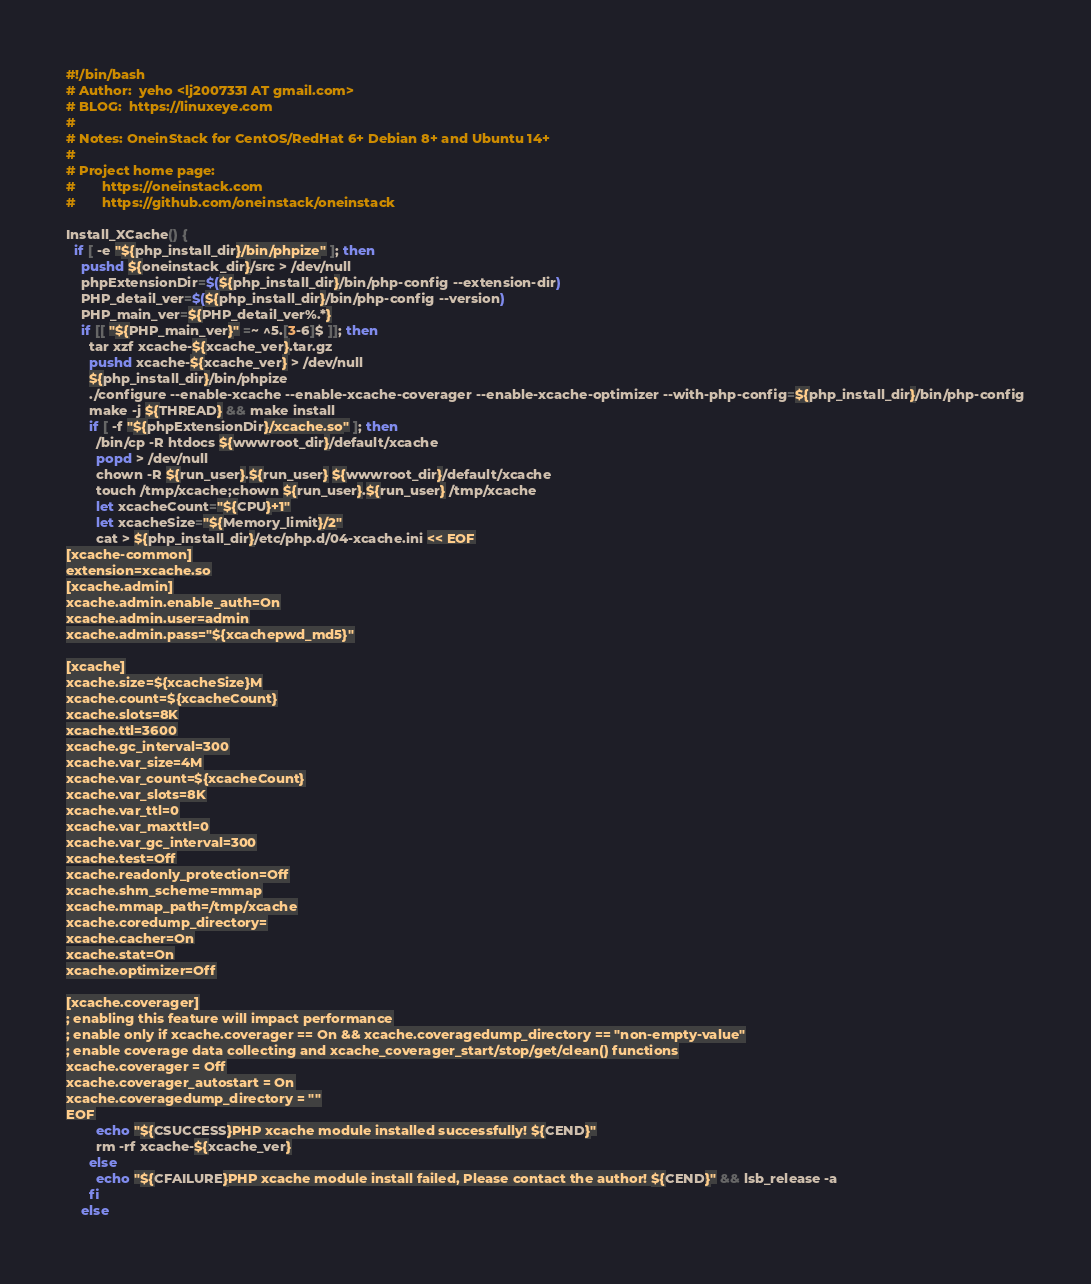Convert code to text. <code><loc_0><loc_0><loc_500><loc_500><_Bash_>#!/bin/bash
# Author:  yeho <lj2007331 AT gmail.com>
# BLOG:  https://linuxeye.com
#
# Notes: OneinStack for CentOS/RedHat 6+ Debian 8+ and Ubuntu 14+
#
# Project home page:
#       https://oneinstack.com
#       https://github.com/oneinstack/oneinstack

Install_XCache() {
  if [ -e "${php_install_dir}/bin/phpize" ]; then
    pushd ${oneinstack_dir}/src > /dev/null
    phpExtensionDir=$(${php_install_dir}/bin/php-config --extension-dir)
    PHP_detail_ver=$(${php_install_dir}/bin/php-config --version)
    PHP_main_ver=${PHP_detail_ver%.*}
    if [[ "${PHP_main_ver}" =~ ^5.[3-6]$ ]]; then
      tar xzf xcache-${xcache_ver}.tar.gz
      pushd xcache-${xcache_ver} > /dev/null
      ${php_install_dir}/bin/phpize
      ./configure --enable-xcache --enable-xcache-coverager --enable-xcache-optimizer --with-php-config=${php_install_dir}/bin/php-config
      make -j ${THREAD} && make install
      if [ -f "${phpExtensionDir}/xcache.so" ]; then
        /bin/cp -R htdocs ${wwwroot_dir}/default/xcache
        popd > /dev/null
        chown -R ${run_user}.${run_user} ${wwwroot_dir}/default/xcache
        touch /tmp/xcache;chown ${run_user}.${run_user} /tmp/xcache
        let xcacheCount="${CPU}+1"
        let xcacheSize="${Memory_limit}/2"
        cat > ${php_install_dir}/etc/php.d/04-xcache.ini << EOF
[xcache-common]
extension=xcache.so
[xcache.admin]
xcache.admin.enable_auth=On
xcache.admin.user=admin
xcache.admin.pass="${xcachepwd_md5}"

[xcache]
xcache.size=${xcacheSize}M
xcache.count=${xcacheCount}
xcache.slots=8K
xcache.ttl=3600
xcache.gc_interval=300
xcache.var_size=4M
xcache.var_count=${xcacheCount}
xcache.var_slots=8K
xcache.var_ttl=0
xcache.var_maxttl=0
xcache.var_gc_interval=300
xcache.test=Off
xcache.readonly_protection=Off
xcache.shm_scheme=mmap
xcache.mmap_path=/tmp/xcache
xcache.coredump_directory=
xcache.cacher=On
xcache.stat=On
xcache.optimizer=Off

[xcache.coverager]
; enabling this feature will impact performance
; enable only if xcache.coverager == On && xcache.coveragedump_directory == "non-empty-value"
; enable coverage data collecting and xcache_coverager_start/stop/get/clean() functions
xcache.coverager = Off
xcache.coverager_autostart = On
xcache.coveragedump_directory = ""
EOF
        echo "${CSUCCESS}PHP xcache module installed successfully! ${CEND}"
        rm -rf xcache-${xcache_ver}
      else
        echo "${CFAILURE}PHP xcache module install failed, Please contact the author! ${CEND}" && lsb_release -a
      fi
    else</code> 